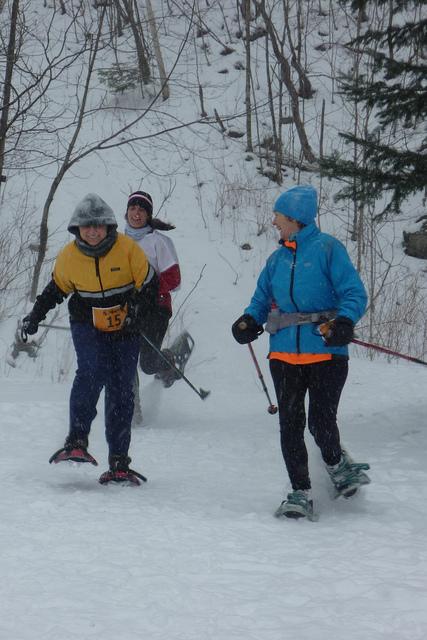How many people are there?
Be succinct. 3. What do these people have on their feet?
Concise answer only. Skis. What do the people have in their hands?
Concise answer only. Ski poles. 